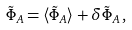<formula> <loc_0><loc_0><loc_500><loc_500>\tilde { \Phi } _ { A } = \langle \tilde { \Phi } _ { A } \rangle + \delta \tilde { \Phi } _ { A } \, ,</formula> 